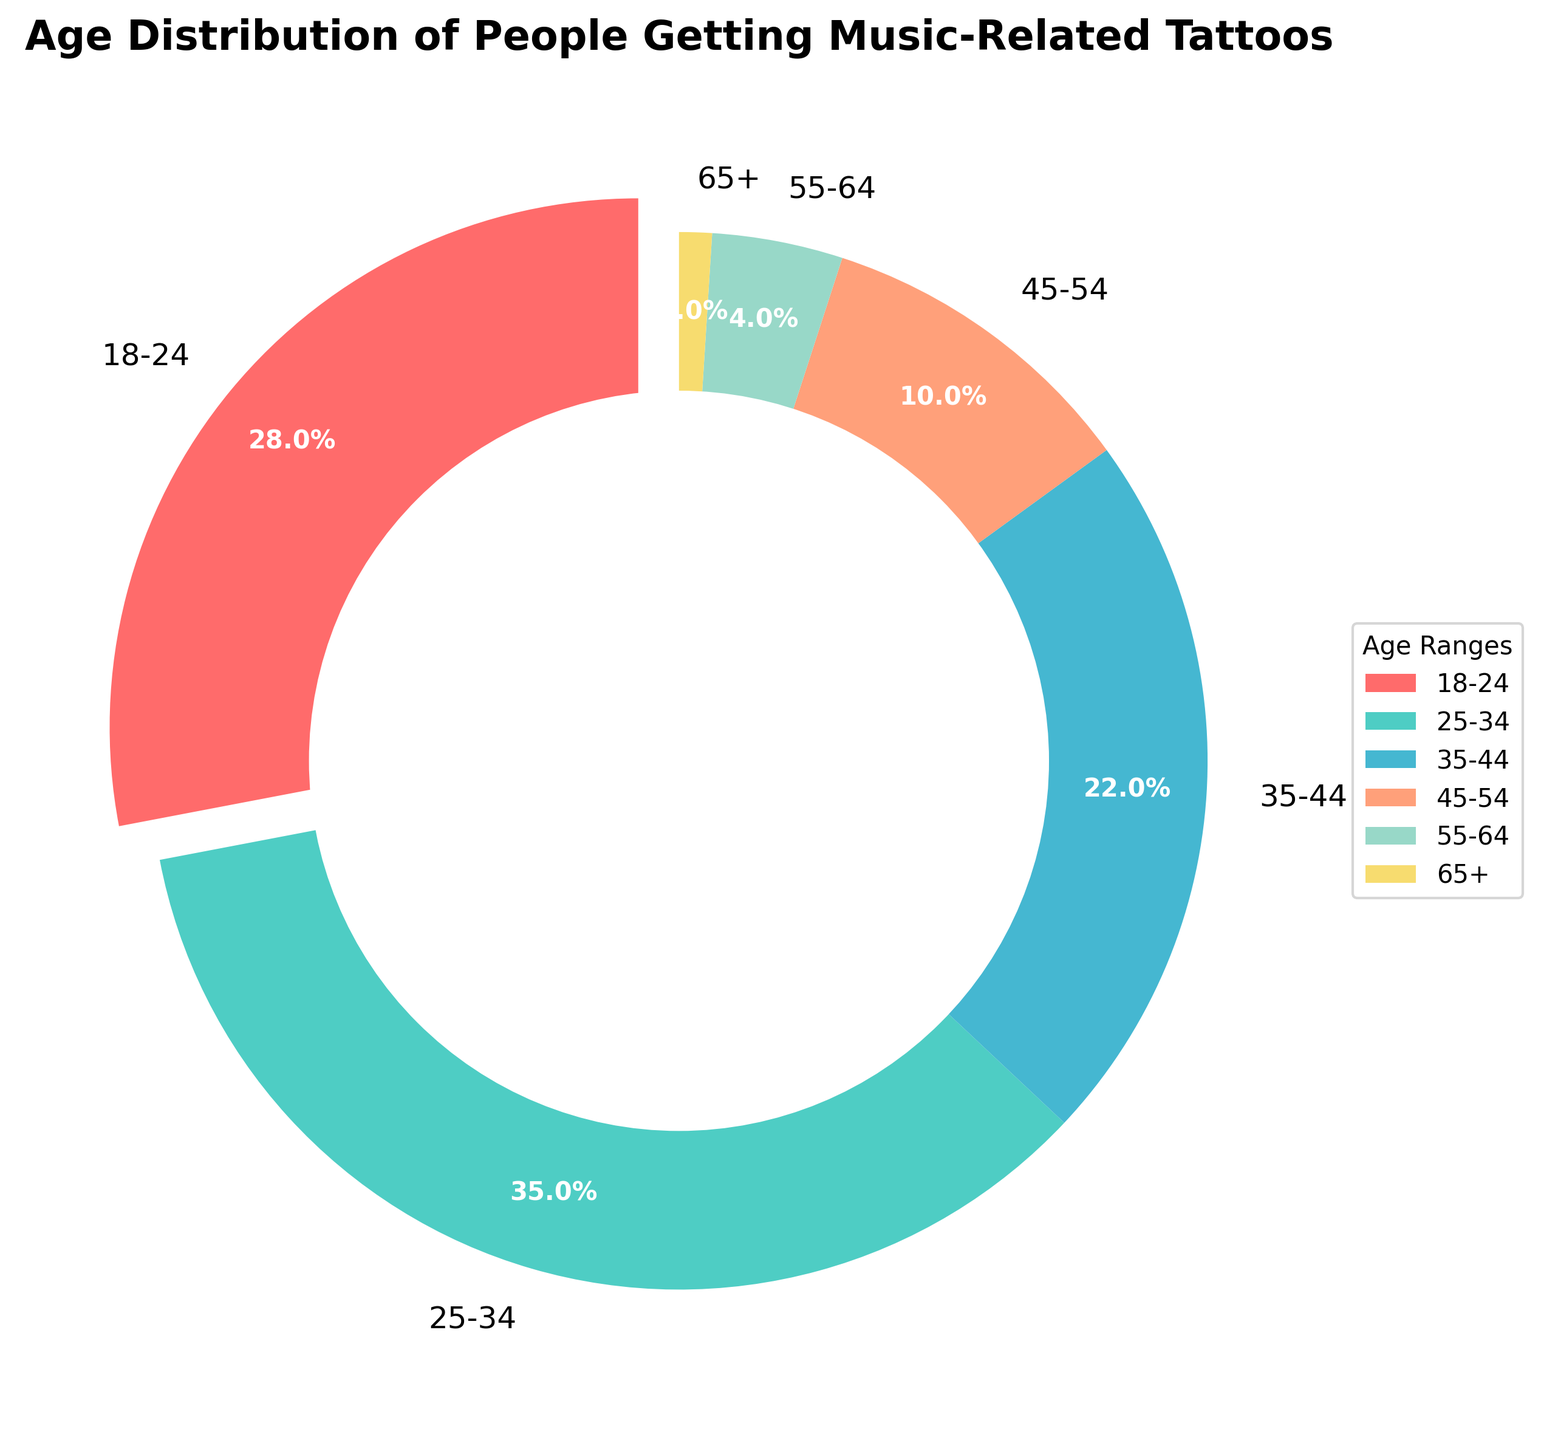Which age group has the highest percentage of people getting music-related tattoos? By referring to the pie chart, we see that the 25-34 age group occupies the largest slice of the chart. The percentage label on this slice confirms it.
Answer: 25-34 Which age group has the lowest percentage of people getting music-related tattoos? Observing the pie chart, the smallest slice corresponds to the 65+ age group, as indicated by the percentage label.
Answer: 65+ Which two age groups together make up more than half of the people getting music-related tattoos? By visually adding the percentages of different slices, we see that 18-24 (28%) and 25-34 (35%) together sum up to 63%, which is more than half.
Answer: 18-24 and 25-34 What percentage of people getting music-related tattoos are 35 or older? Adding the slices for 35-44 (22%), 45-54 (10%), 55-64 (4%), and 65+ (1%), we get 22% + 10% + 4% + 1% = 37%.
Answer: 37% Which age group has a slightly smaller percentage than the 35-44 age group? Comparing the percentage labels, the 45-54 age group at 10% is slightly smaller than the 35-44 age group at 22%.
Answer: 45-54 By how many percentage points does the 25-34 age group exceed the 18-24 age group in getting music-related tattoos? Subtracting the percentage of the 18-24 group (28%) from the 25-34 group (35%) gives us 35% - 28% = 7%.
Answer: 7 How much larger is the 18-24 age group compared to the 55-64 age group in the percentage of people getting music-related tattoos? The difference between the percentages of the 18-24 group (28%) and the 55-64 group (4%) is 28% - 4% = 24%.
Answer: 24 If a person is randomly chosen from the group of people getting music-related tattoos, what is the probability (in percentage) that they are younger than 35? Adding the percentages of the 18-24 (28%) and 25-34 (35%) groups gives us 28% + 35% = 63%.
Answer: 63 What is the ratio of people getting music-related tattoos in the 35-44 age group to those in the 65+ age group? The percentage for the 35-44 group is 22% and for the 65+ group is 1%. So, the ratio is 22:1.
Answer: 22:1 